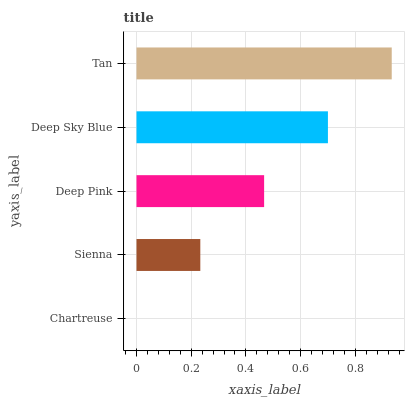Is Chartreuse the minimum?
Answer yes or no. Yes. Is Tan the maximum?
Answer yes or no. Yes. Is Sienna the minimum?
Answer yes or no. No. Is Sienna the maximum?
Answer yes or no. No. Is Sienna greater than Chartreuse?
Answer yes or no. Yes. Is Chartreuse less than Sienna?
Answer yes or no. Yes. Is Chartreuse greater than Sienna?
Answer yes or no. No. Is Sienna less than Chartreuse?
Answer yes or no. No. Is Deep Pink the high median?
Answer yes or no. Yes. Is Deep Pink the low median?
Answer yes or no. Yes. Is Tan the high median?
Answer yes or no. No. Is Deep Sky Blue the low median?
Answer yes or no. No. 